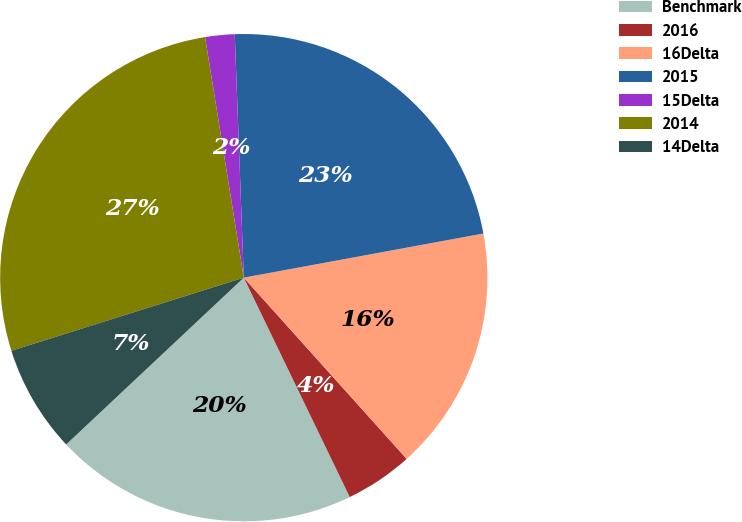Convert chart. <chart><loc_0><loc_0><loc_500><loc_500><pie_chart><fcel>Benchmark<fcel>2016<fcel>16Delta<fcel>2015<fcel>15Delta<fcel>2014<fcel>14Delta<nl><fcel>20.16%<fcel>4.49%<fcel>16.25%<fcel>22.69%<fcel>1.95%<fcel>27.31%<fcel>7.15%<nl></chart> 